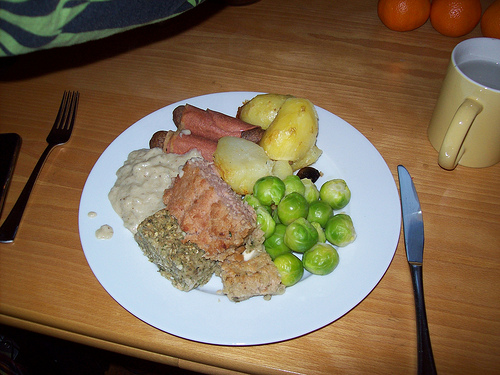<image>
Is the fork behind the plate? No. The fork is not behind the plate. From this viewpoint, the fork appears to be positioned elsewhere in the scene. 